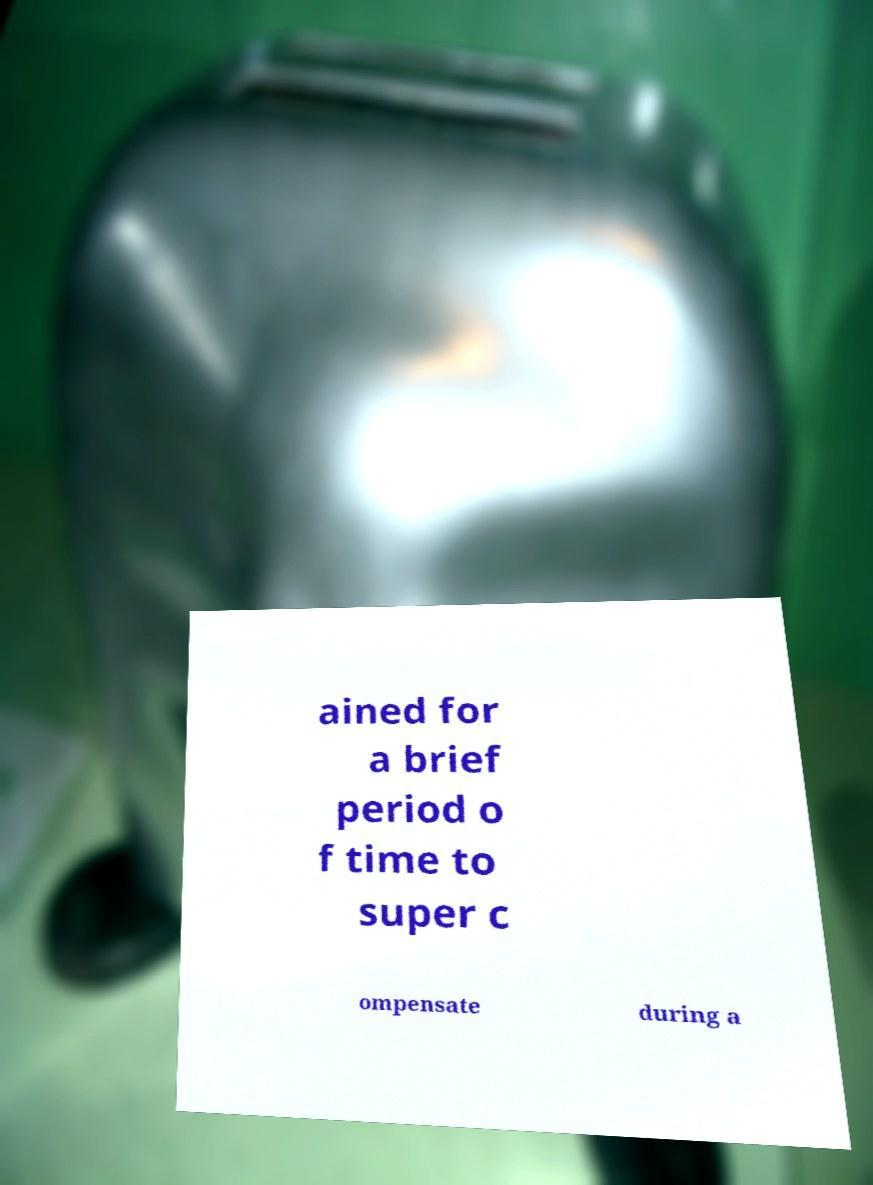I need the written content from this picture converted into text. Can you do that? ained for a brief period o f time to super c ompensate during a 